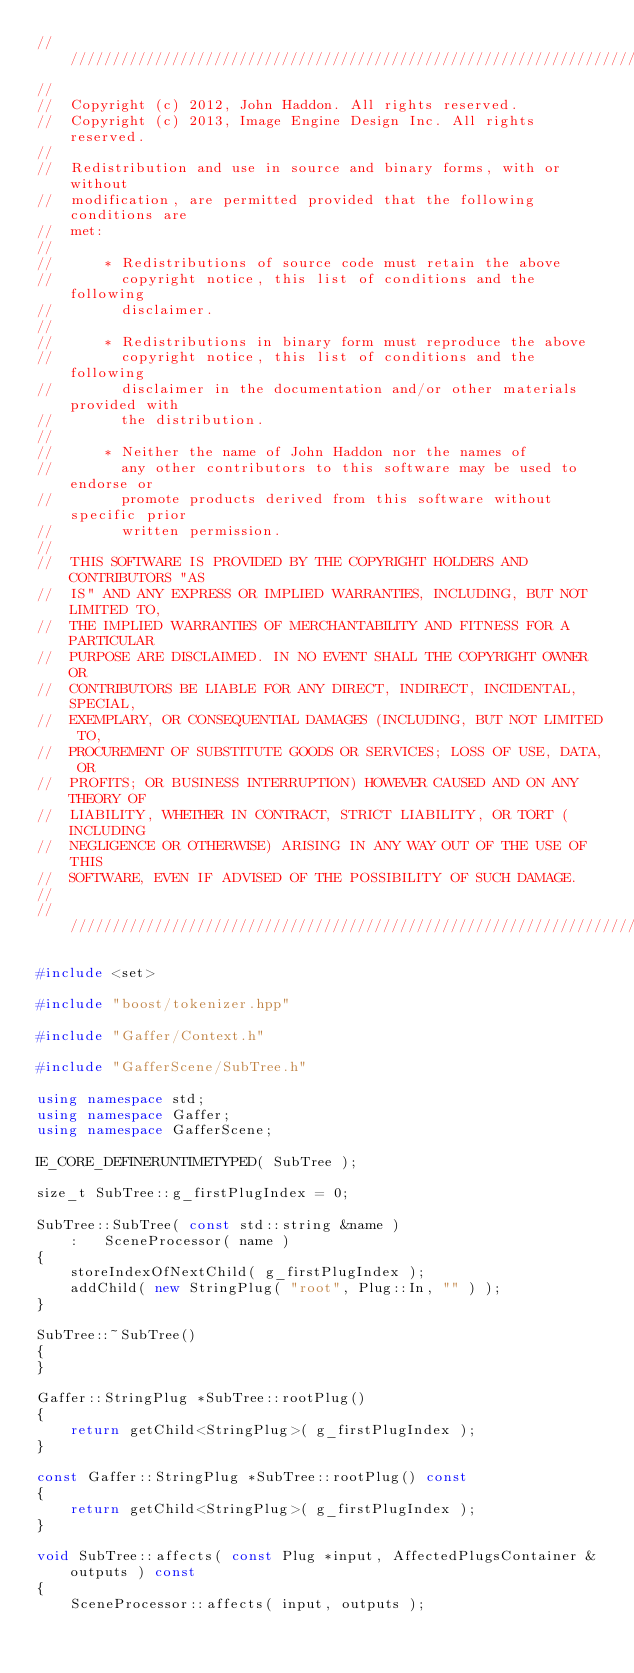Convert code to text. <code><loc_0><loc_0><loc_500><loc_500><_C++_>//////////////////////////////////////////////////////////////////////////
//  
//  Copyright (c) 2012, John Haddon. All rights reserved.
//  Copyright (c) 2013, Image Engine Design Inc. All rights reserved.
//  
//  Redistribution and use in source and binary forms, with or without
//  modification, are permitted provided that the following conditions are
//  met:
//  
//      * Redistributions of source code must retain the above
//        copyright notice, this list of conditions and the following
//        disclaimer.
//  
//      * Redistributions in binary form must reproduce the above
//        copyright notice, this list of conditions and the following
//        disclaimer in the documentation and/or other materials provided with
//        the distribution.
//  
//      * Neither the name of John Haddon nor the names of
//        any other contributors to this software may be used to endorse or
//        promote products derived from this software without specific prior
//        written permission.
//  
//  THIS SOFTWARE IS PROVIDED BY THE COPYRIGHT HOLDERS AND CONTRIBUTORS "AS
//  IS" AND ANY EXPRESS OR IMPLIED WARRANTIES, INCLUDING, BUT NOT LIMITED TO,
//  THE IMPLIED WARRANTIES OF MERCHANTABILITY AND FITNESS FOR A PARTICULAR
//  PURPOSE ARE DISCLAIMED. IN NO EVENT SHALL THE COPYRIGHT OWNER OR
//  CONTRIBUTORS BE LIABLE FOR ANY DIRECT, INDIRECT, INCIDENTAL, SPECIAL,
//  EXEMPLARY, OR CONSEQUENTIAL DAMAGES (INCLUDING, BUT NOT LIMITED TO,
//  PROCUREMENT OF SUBSTITUTE GOODS OR SERVICES; LOSS OF USE, DATA, OR
//  PROFITS; OR BUSINESS INTERRUPTION) HOWEVER CAUSED AND ON ANY THEORY OF
//  LIABILITY, WHETHER IN CONTRACT, STRICT LIABILITY, OR TORT (INCLUDING
//  NEGLIGENCE OR OTHERWISE) ARISING IN ANY WAY OUT OF THE USE OF THIS
//  SOFTWARE, EVEN IF ADVISED OF THE POSSIBILITY OF SUCH DAMAGE.
//  
//////////////////////////////////////////////////////////////////////////

#include <set>

#include "boost/tokenizer.hpp"

#include "Gaffer/Context.h"

#include "GafferScene/SubTree.h"

using namespace std;
using namespace Gaffer;
using namespace GafferScene;

IE_CORE_DEFINERUNTIMETYPED( SubTree );

size_t SubTree::g_firstPlugIndex = 0;

SubTree::SubTree( const std::string &name )
	:	SceneProcessor( name )
{
	storeIndexOfNextChild( g_firstPlugIndex );
	addChild( new StringPlug( "root", Plug::In, "" ) );
}

SubTree::~SubTree()
{
}

Gaffer::StringPlug *SubTree::rootPlug()
{
	return getChild<StringPlug>( g_firstPlugIndex );
}

const Gaffer::StringPlug *SubTree::rootPlug() const
{
	return getChild<StringPlug>( g_firstPlugIndex );
}

void SubTree::affects( const Plug *input, AffectedPlugsContainer &outputs ) const
{
	SceneProcessor::affects( input, outputs );
	</code> 